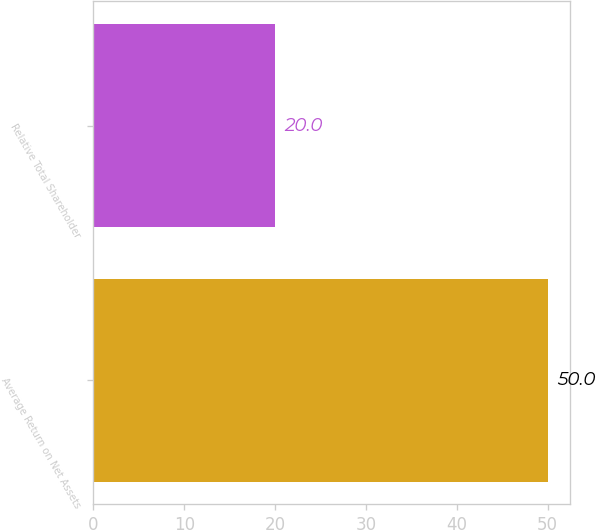Convert chart to OTSL. <chart><loc_0><loc_0><loc_500><loc_500><bar_chart><fcel>Average Return on Net Assets<fcel>Relative Total Shareholder<nl><fcel>50<fcel>20<nl></chart> 